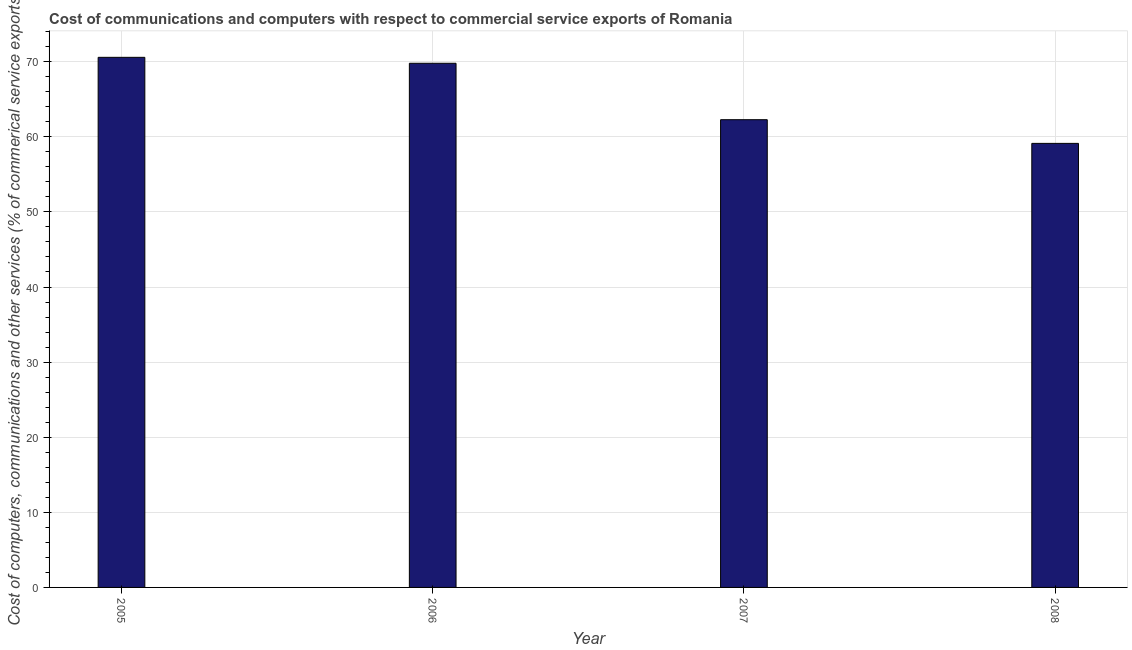What is the title of the graph?
Provide a succinct answer. Cost of communications and computers with respect to commercial service exports of Romania. What is the label or title of the Y-axis?
Offer a terse response. Cost of computers, communications and other services (% of commerical service exports). What is the cost of communications in 2005?
Your answer should be very brief. 70.58. Across all years, what is the maximum  computer and other services?
Ensure brevity in your answer.  70.58. Across all years, what is the minimum cost of communications?
Give a very brief answer. 59.12. In which year was the  computer and other services minimum?
Give a very brief answer. 2008. What is the sum of the cost of communications?
Offer a very short reply. 261.78. What is the difference between the  computer and other services in 2005 and 2007?
Your response must be concise. 8.3. What is the average cost of communications per year?
Give a very brief answer. 65.44. What is the median  computer and other services?
Make the answer very short. 66.03. Is the  computer and other services in 2007 less than that in 2008?
Your answer should be very brief. No. What is the difference between the highest and the second highest cost of communications?
Provide a short and direct response. 0.79. Is the sum of the  computer and other services in 2005 and 2008 greater than the maximum  computer and other services across all years?
Make the answer very short. Yes. What is the difference between the highest and the lowest cost of communications?
Make the answer very short. 11.46. In how many years, is the cost of communications greater than the average cost of communications taken over all years?
Your answer should be very brief. 2. How many years are there in the graph?
Offer a very short reply. 4. What is the difference between two consecutive major ticks on the Y-axis?
Provide a short and direct response. 10. Are the values on the major ticks of Y-axis written in scientific E-notation?
Ensure brevity in your answer.  No. What is the Cost of computers, communications and other services (% of commerical service exports) of 2005?
Give a very brief answer. 70.58. What is the Cost of computers, communications and other services (% of commerical service exports) of 2006?
Keep it short and to the point. 69.79. What is the Cost of computers, communications and other services (% of commerical service exports) in 2007?
Ensure brevity in your answer.  62.28. What is the Cost of computers, communications and other services (% of commerical service exports) of 2008?
Keep it short and to the point. 59.12. What is the difference between the Cost of computers, communications and other services (% of commerical service exports) in 2005 and 2006?
Ensure brevity in your answer.  0.79. What is the difference between the Cost of computers, communications and other services (% of commerical service exports) in 2005 and 2007?
Provide a short and direct response. 8.3. What is the difference between the Cost of computers, communications and other services (% of commerical service exports) in 2005 and 2008?
Make the answer very short. 11.46. What is the difference between the Cost of computers, communications and other services (% of commerical service exports) in 2006 and 2007?
Provide a short and direct response. 7.51. What is the difference between the Cost of computers, communications and other services (% of commerical service exports) in 2006 and 2008?
Make the answer very short. 10.67. What is the difference between the Cost of computers, communications and other services (% of commerical service exports) in 2007 and 2008?
Provide a short and direct response. 3.15. What is the ratio of the Cost of computers, communications and other services (% of commerical service exports) in 2005 to that in 2007?
Ensure brevity in your answer.  1.13. What is the ratio of the Cost of computers, communications and other services (% of commerical service exports) in 2005 to that in 2008?
Ensure brevity in your answer.  1.19. What is the ratio of the Cost of computers, communications and other services (% of commerical service exports) in 2006 to that in 2007?
Offer a terse response. 1.12. What is the ratio of the Cost of computers, communications and other services (% of commerical service exports) in 2006 to that in 2008?
Ensure brevity in your answer.  1.18. What is the ratio of the Cost of computers, communications and other services (% of commerical service exports) in 2007 to that in 2008?
Offer a terse response. 1.05. 